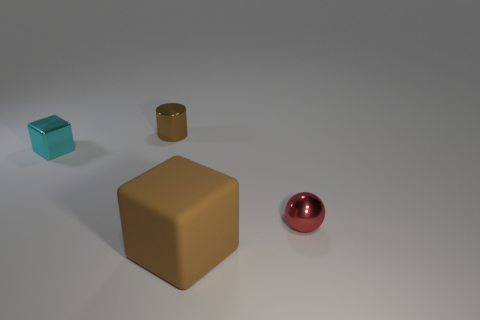What shape is the tiny thing on the left side of the brown object that is behind the sphere? The tiny object on the left side of the brown cube, which is situated behind the reddish sphere, appears to be a cube as well. It's somewhat difficult to discern its exact shape due to its small size, but it reflects light in a way that suggests it has multiple flat surfaces indicative of a cube. 